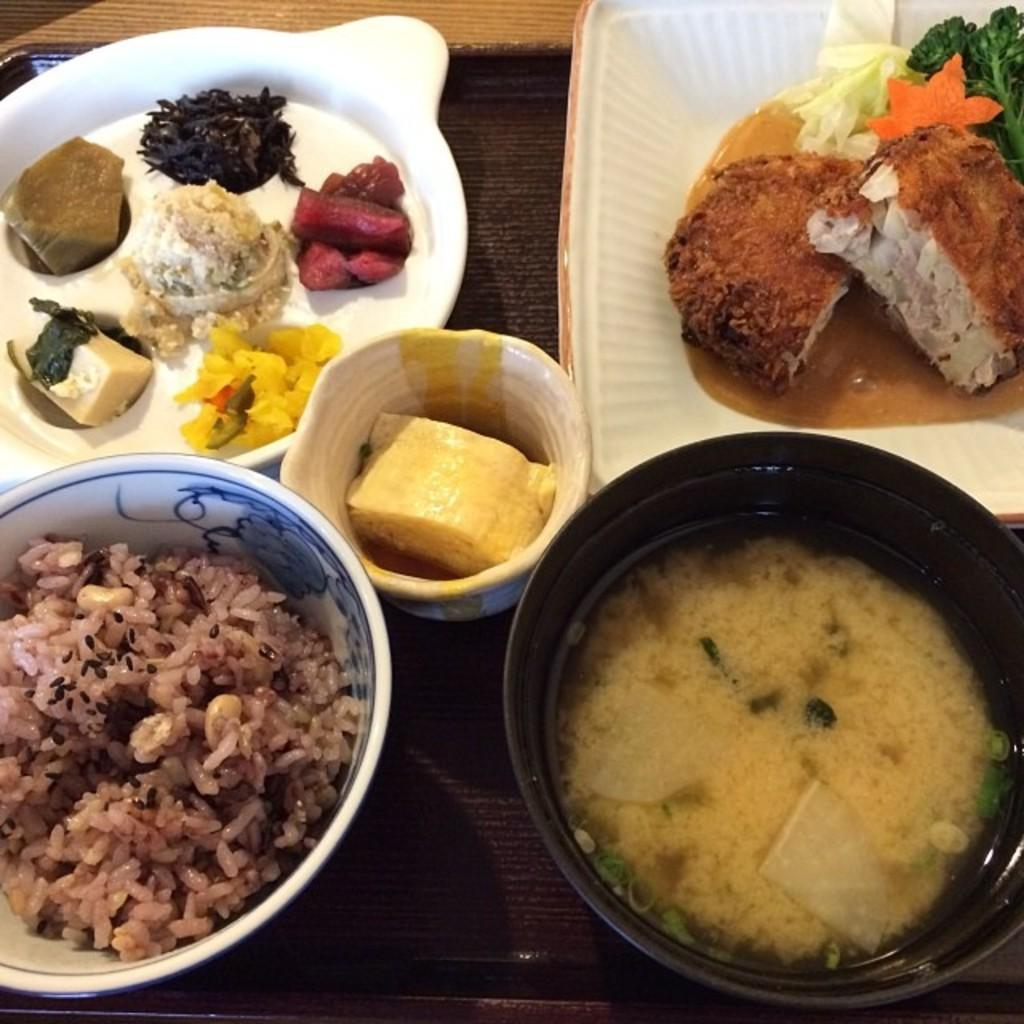What types of items can be seen in the image? There are different food items and desserts in the image. Where are the food items and desserts located? They are served on a table and kept in a tray. How is the tray placed on the table? The tray is placed on the table. Can you tell me how many boys are serving the food in the image? There is no boy or servant present in the image; the focus is on the food items and desserts. 